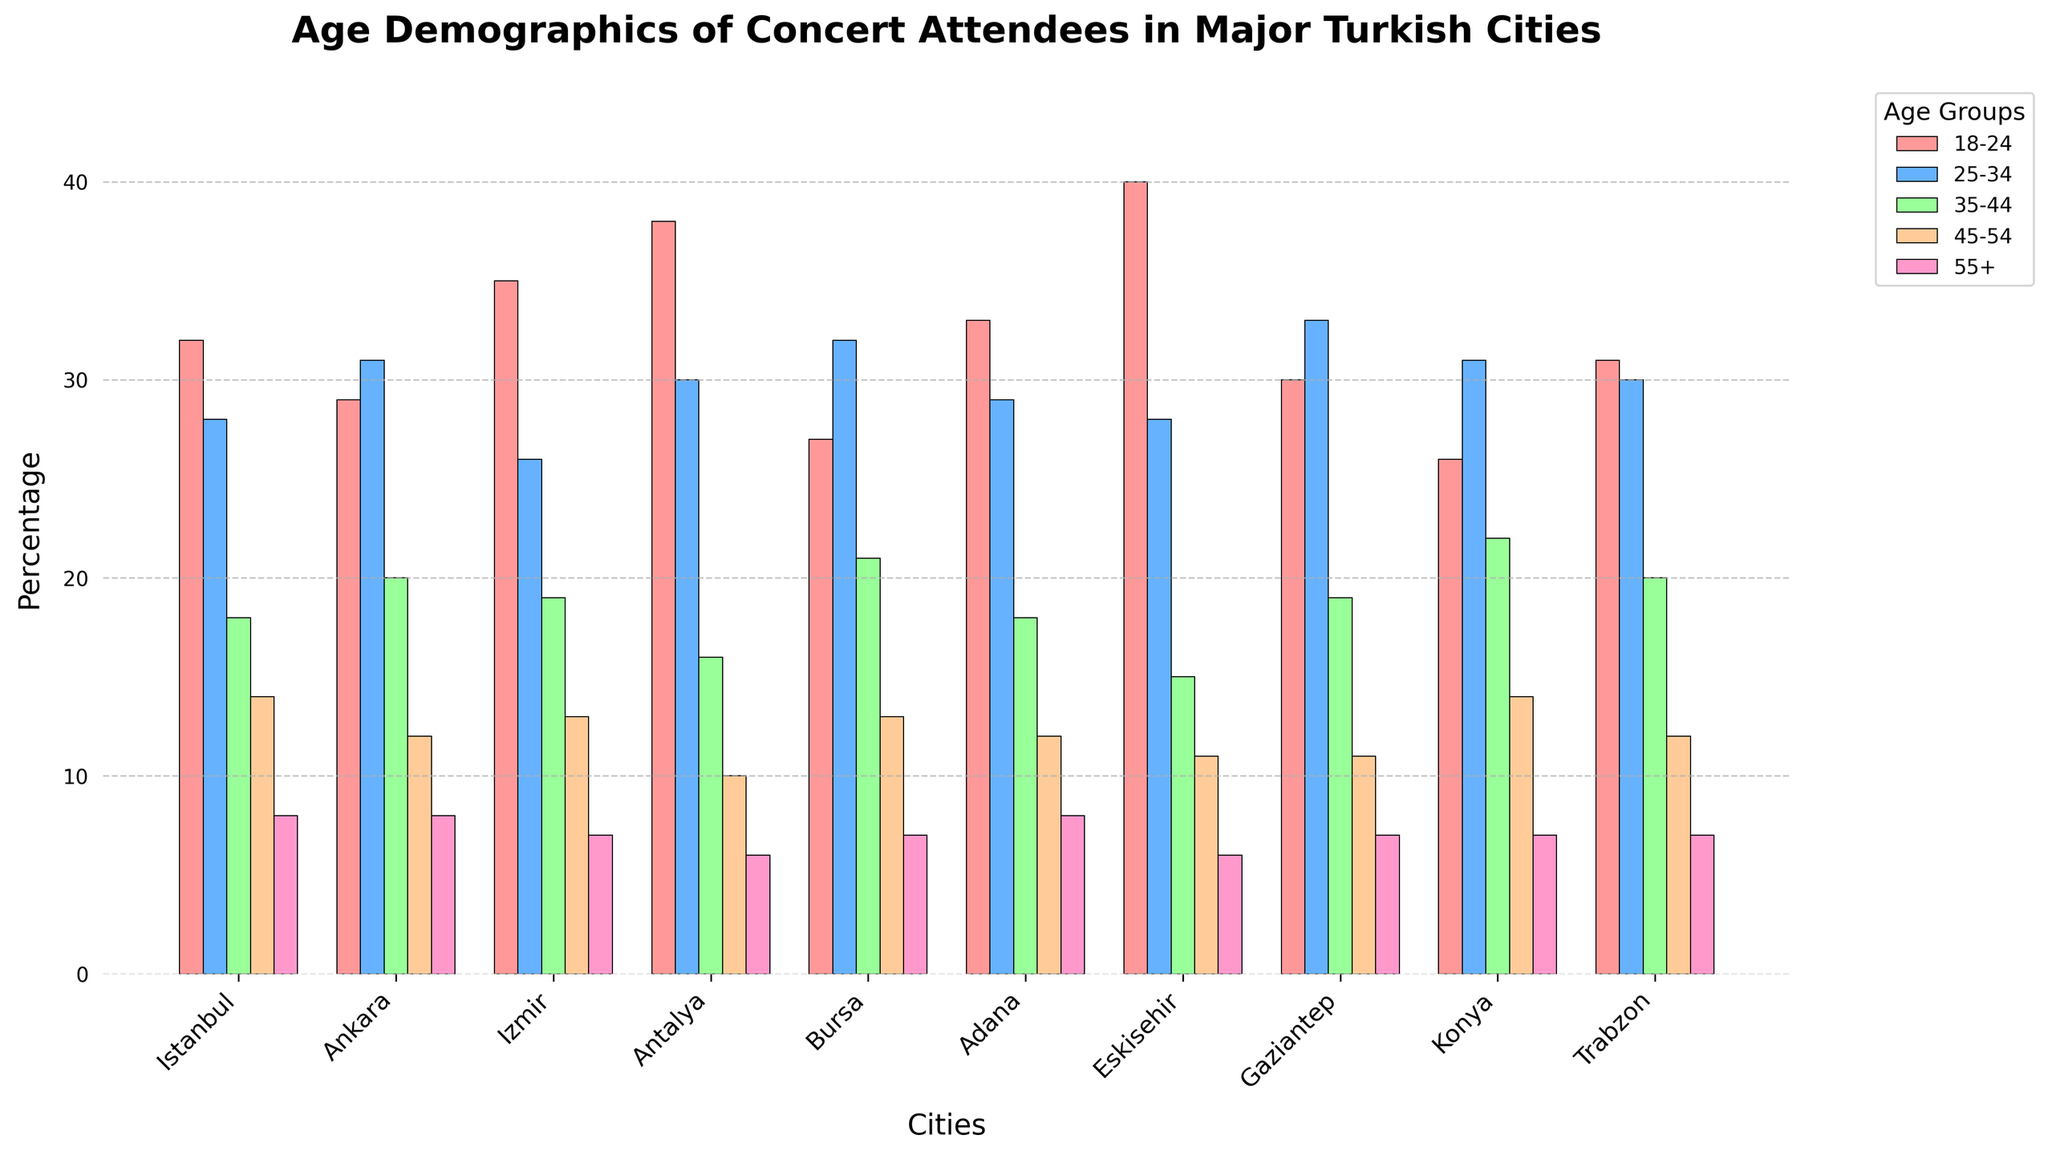What is the percentage of concert attendees aged 18-24 in Eskisehir? In the bar chart, find the bar for Eskisehir and check the height associated with the '18-24' age group.
Answer: 40 Which city has the highest percentage of concert attendees aged 45-54? Look for the tallest bar in the '45-54' age group across all cities.
Answer: Istanbul If you consider the groups 18-24 and 25-34 combined, which city has the highest total percentage? Add the percentages for the '18-24' and '25-34' age groups for each city, and identify the highest sum. Eskisehir: 40 + 28 = 68, Antalya: 38 + 30 = 68, Istanbul: 32 + 28 = 60, etc.
Answer: Eskisehir and Antalya Which age group has the most uniform distribution across all cities? Compare the heights of the bars within each age group across the cities, looking for the smallest variation.
Answer: 55+ What city has the smallest percentage of concert attendees aged 55 and older? Look for the shortest bar in the '55+' age group across all cities.
Answer: Antalya Which city has the largest difference between the highest and the lowest age groups? For each city, subtract the percentage of the lowest age group ('55+') from the highest age group ('18-24'). Identify the city with the largest difference.
Answer: Eskisehir How does the percentage of attendees aged 25-34 in Konya compare to Ankara? Locate the bars for the '25-34' age group in Konya and Ankara and compare their heights.
Answer: Konya is slightly less than Ankara What is the average percentage of concert attendees aged 35-44 across all cities? Sum the percentages of the '35-44' age group for all cities and divide by the number of cities (Sum: 18 + 20 + 19 + 16 + 21 + 18 + 15 + 19 + 22 + 20 = 188. Average: 188 / 10 = 18.8).
Answer: 18.8 How many cities have more than 30% of concert attendees aged 18-24? Count the bars in the '18-24' age group that have a height greater than 30%.
Answer: 5 